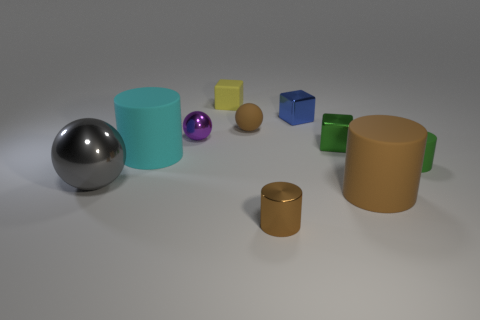Are there any gray things that have the same shape as the large brown rubber thing?
Offer a terse response. No. Are there the same number of big gray objects that are to the left of the large ball and large brown matte cylinders?
Provide a succinct answer. No. What is the material of the small green object in front of the large rubber thing that is left of the tiny yellow block?
Your answer should be compact. Rubber. What is the shape of the small purple metallic thing?
Offer a very short reply. Sphere. Are there the same number of gray shiny spheres that are on the right side of the small blue shiny object and small spheres that are behind the tiny purple shiny object?
Make the answer very short. No. Is the color of the tiny cylinder left of the small green rubber cylinder the same as the large rubber cylinder that is right of the yellow matte block?
Offer a very short reply. Yes. Are there more large things to the left of the tiny green matte cylinder than large cyan cylinders?
Provide a short and direct response. Yes. What is the shape of the large brown thing that is the same material as the brown sphere?
Make the answer very short. Cylinder. There is a green object in front of the cyan rubber object; does it have the same size as the large cyan thing?
Give a very brief answer. No. The brown rubber thing that is to the right of the tiny brown object that is right of the tiny brown rubber sphere is what shape?
Your response must be concise. Cylinder. 